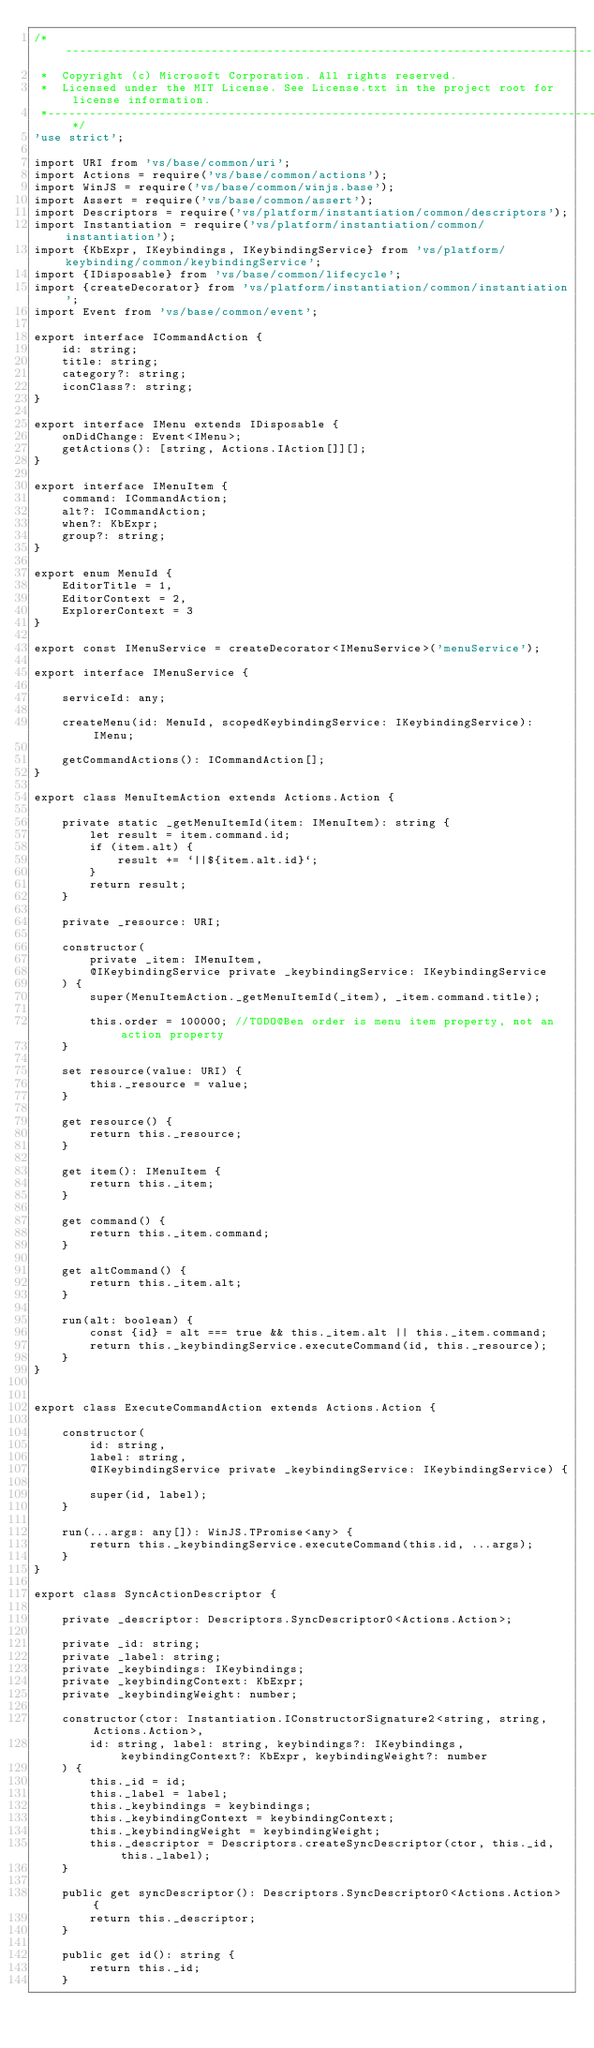Convert code to text. <code><loc_0><loc_0><loc_500><loc_500><_TypeScript_>/*---------------------------------------------------------------------------------------------
 *  Copyright (c) Microsoft Corporation. All rights reserved.
 *  Licensed under the MIT License. See License.txt in the project root for license information.
 *--------------------------------------------------------------------------------------------*/
'use strict';

import URI from 'vs/base/common/uri';
import Actions = require('vs/base/common/actions');
import WinJS = require('vs/base/common/winjs.base');
import Assert = require('vs/base/common/assert');
import Descriptors = require('vs/platform/instantiation/common/descriptors');
import Instantiation = require('vs/platform/instantiation/common/instantiation');
import {KbExpr, IKeybindings, IKeybindingService} from 'vs/platform/keybinding/common/keybindingService';
import {IDisposable} from 'vs/base/common/lifecycle';
import {createDecorator} from 'vs/platform/instantiation/common/instantiation';
import Event from 'vs/base/common/event';

export interface ICommandAction {
	id: string;
	title: string;
	category?: string;
	iconClass?: string;
}

export interface IMenu extends IDisposable {
	onDidChange: Event<IMenu>;
	getActions(): [string, Actions.IAction[]][];
}

export interface IMenuItem {
	command: ICommandAction;
	alt?: ICommandAction;
	when?: KbExpr;
	group?: string;
}

export enum MenuId {
	EditorTitle = 1,
	EditorContext = 2,
	ExplorerContext = 3
}

export const IMenuService = createDecorator<IMenuService>('menuService');

export interface IMenuService {

	serviceId: any;

	createMenu(id: MenuId, scopedKeybindingService: IKeybindingService): IMenu;

	getCommandActions(): ICommandAction[];
}

export class MenuItemAction extends Actions.Action {

	private static _getMenuItemId(item: IMenuItem): string {
		let result = item.command.id;
		if (item.alt) {
			result += `||${item.alt.id}`;
		}
		return result;
	}

	private _resource: URI;

	constructor(
		private _item: IMenuItem,
		@IKeybindingService private _keybindingService: IKeybindingService
	) {
		super(MenuItemAction._getMenuItemId(_item), _item.command.title);

		this.order = 100000; //TODO@Ben order is menu item property, not an action property
	}

	set resource(value: URI) {
		this._resource = value;
	}

	get resource() {
		return this._resource;
	}

	get item(): IMenuItem {
		return this._item;
	}

	get command() {
		return this._item.command;
	}

	get altCommand() {
		return this._item.alt;
	}

	run(alt: boolean) {
		const {id} = alt === true && this._item.alt || this._item.command;
		return this._keybindingService.executeCommand(id, this._resource);
	}
}


export class ExecuteCommandAction extends Actions.Action {

	constructor(
		id: string,
		label: string,
		@IKeybindingService private _keybindingService: IKeybindingService) {

		super(id, label);
	}

	run(...args: any[]): WinJS.TPromise<any> {
		return this._keybindingService.executeCommand(this.id, ...args);
	}
}

export class SyncActionDescriptor {

	private _descriptor: Descriptors.SyncDescriptor0<Actions.Action>;

	private _id: string;
	private _label: string;
	private _keybindings: IKeybindings;
	private _keybindingContext: KbExpr;
	private _keybindingWeight: number;

	constructor(ctor: Instantiation.IConstructorSignature2<string, string, Actions.Action>,
		id: string, label: string, keybindings?: IKeybindings, keybindingContext?: KbExpr, keybindingWeight?: number
	) {
		this._id = id;
		this._label = label;
		this._keybindings = keybindings;
		this._keybindingContext = keybindingContext;
		this._keybindingWeight = keybindingWeight;
		this._descriptor = Descriptors.createSyncDescriptor(ctor, this._id, this._label);
	}

	public get syncDescriptor(): Descriptors.SyncDescriptor0<Actions.Action> {
		return this._descriptor;
	}

	public get id(): string {
		return this._id;
	}
</code> 